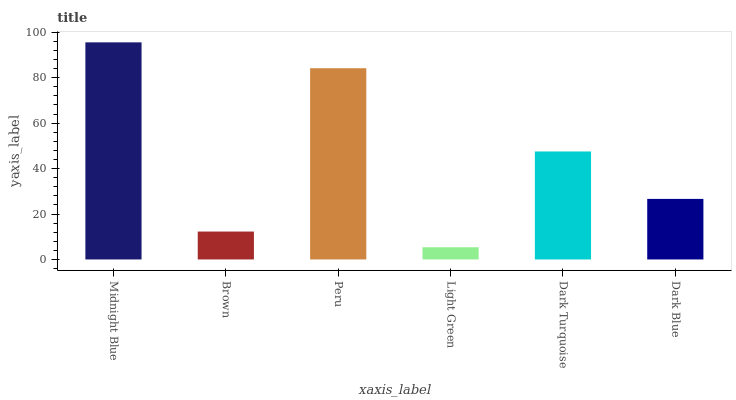Is Brown the minimum?
Answer yes or no. No. Is Brown the maximum?
Answer yes or no. No. Is Midnight Blue greater than Brown?
Answer yes or no. Yes. Is Brown less than Midnight Blue?
Answer yes or no. Yes. Is Brown greater than Midnight Blue?
Answer yes or no. No. Is Midnight Blue less than Brown?
Answer yes or no. No. Is Dark Turquoise the high median?
Answer yes or no. Yes. Is Dark Blue the low median?
Answer yes or no. Yes. Is Dark Blue the high median?
Answer yes or no. No. Is Light Green the low median?
Answer yes or no. No. 